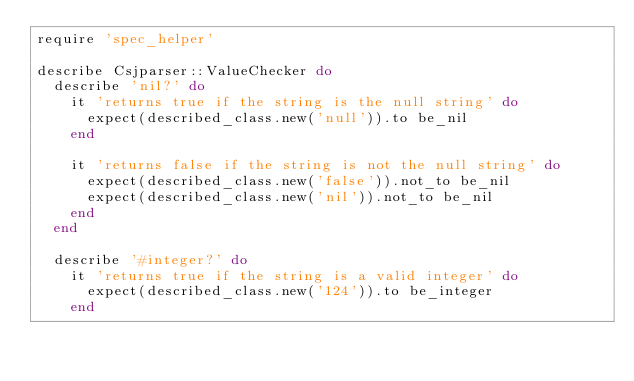Convert code to text. <code><loc_0><loc_0><loc_500><loc_500><_Ruby_>require 'spec_helper'

describe Csjparser::ValueChecker do
  describe 'nil?' do
    it 'returns true if the string is the null string' do
      expect(described_class.new('null')).to be_nil
    end

    it 'returns false if the string is not the null string' do
      expect(described_class.new('false')).not_to be_nil
      expect(described_class.new('nil')).not_to be_nil
    end
  end

  describe '#integer?' do
    it 'returns true if the string is a valid integer' do
      expect(described_class.new('124')).to be_integer
    end
</code> 